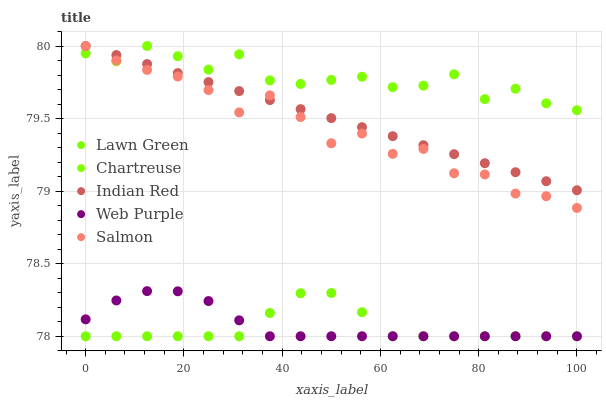Does Lawn Green have the minimum area under the curve?
Answer yes or no. Yes. Does Chartreuse have the maximum area under the curve?
Answer yes or no. Yes. Does Salmon have the minimum area under the curve?
Answer yes or no. No. Does Salmon have the maximum area under the curve?
Answer yes or no. No. Is Indian Red the smoothest?
Answer yes or no. Yes. Is Salmon the roughest?
Answer yes or no. Yes. Is Chartreuse the smoothest?
Answer yes or no. No. Is Chartreuse the roughest?
Answer yes or no. No. Does Lawn Green have the lowest value?
Answer yes or no. Yes. Does Salmon have the lowest value?
Answer yes or no. No. Does Indian Red have the highest value?
Answer yes or no. Yes. Does Web Purple have the highest value?
Answer yes or no. No. Is Lawn Green less than Salmon?
Answer yes or no. Yes. Is Salmon greater than Web Purple?
Answer yes or no. Yes. Does Indian Red intersect Chartreuse?
Answer yes or no. Yes. Is Indian Red less than Chartreuse?
Answer yes or no. No. Is Indian Red greater than Chartreuse?
Answer yes or no. No. Does Lawn Green intersect Salmon?
Answer yes or no. No. 